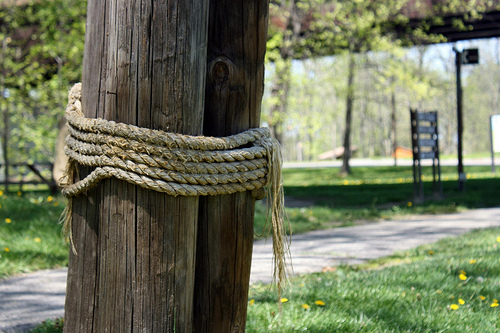<image>
Is the rope above the grass? Yes. The rope is positioned above the grass in the vertical space, higher up in the scene. 